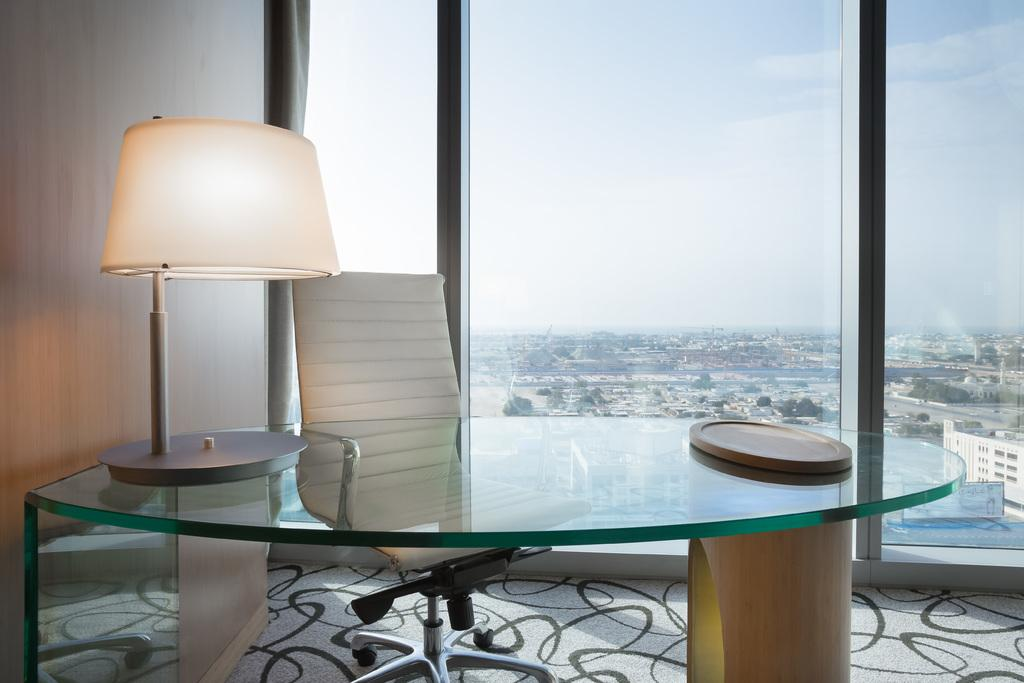What type of table is visible in the image? There is a glass table in the image. What type of furniture is present besides the table? There is a chair in the image. What can be seen through the glass window in the image? The glass window in the image allows a view of the outside. What type of pear is sitting on the chair in the image? There is no pear present in the image; it only features a glass table, a chair, and a glass window. 